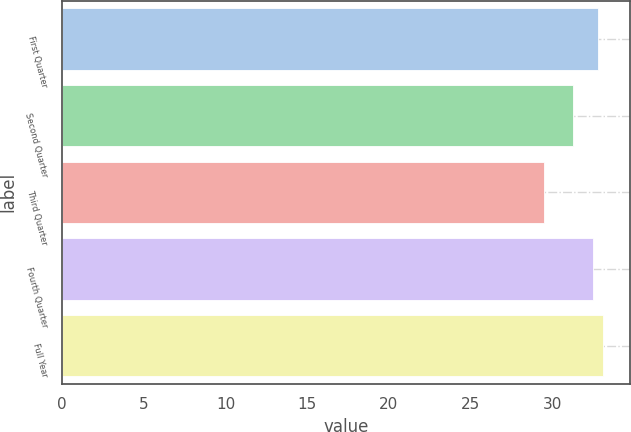<chart> <loc_0><loc_0><loc_500><loc_500><bar_chart><fcel>First Quarter<fcel>Second Quarter<fcel>Third Quarter<fcel>Fourth Quarter<fcel>Full Year<nl><fcel>32.79<fcel>31.29<fcel>29.49<fcel>32.47<fcel>33.11<nl></chart> 